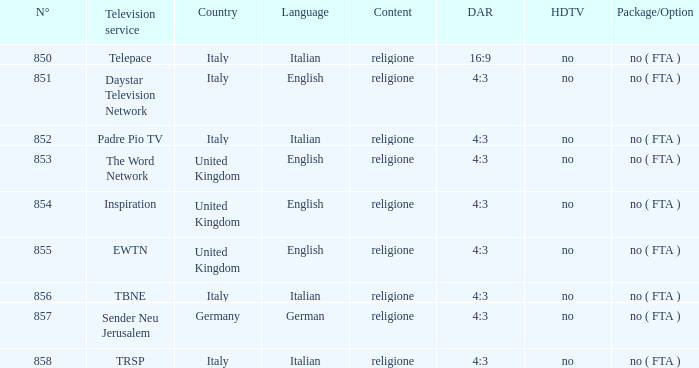Can you give me this table as a dict? {'header': ['N°', 'Television service', 'Country', 'Language', 'Content', 'DAR', 'HDTV', 'Package/Option'], 'rows': [['850', 'Telepace', 'Italy', 'Italian', 'religione', '16:9', 'no', 'no ( FTA )'], ['851', 'Daystar Television Network', 'Italy', 'English', 'religione', '4:3', 'no', 'no ( FTA )'], ['852', 'Padre Pio TV', 'Italy', 'Italian', 'religione', '4:3', 'no', 'no ( FTA )'], ['853', 'The Word Network', 'United Kingdom', 'English', 'religione', '4:3', 'no', 'no ( FTA )'], ['854', 'Inspiration', 'United Kingdom', 'English', 'religione', '4:3', 'no', 'no ( FTA )'], ['855', 'EWTN', 'United Kingdom', 'English', 'religione', '4:3', 'no', 'no ( FTA )'], ['856', 'TBNE', 'Italy', 'Italian', 'religione', '4:3', 'no', 'no ( FTA )'], ['857', 'Sender Neu Jerusalem', 'Germany', 'German', 'religione', '4:3', 'no', 'no ( FTA )'], ['858', 'TRSP', 'Italy', 'Italian', 'religione', '4:3', 'no', 'no ( FTA )']]} 0? EWTN. 